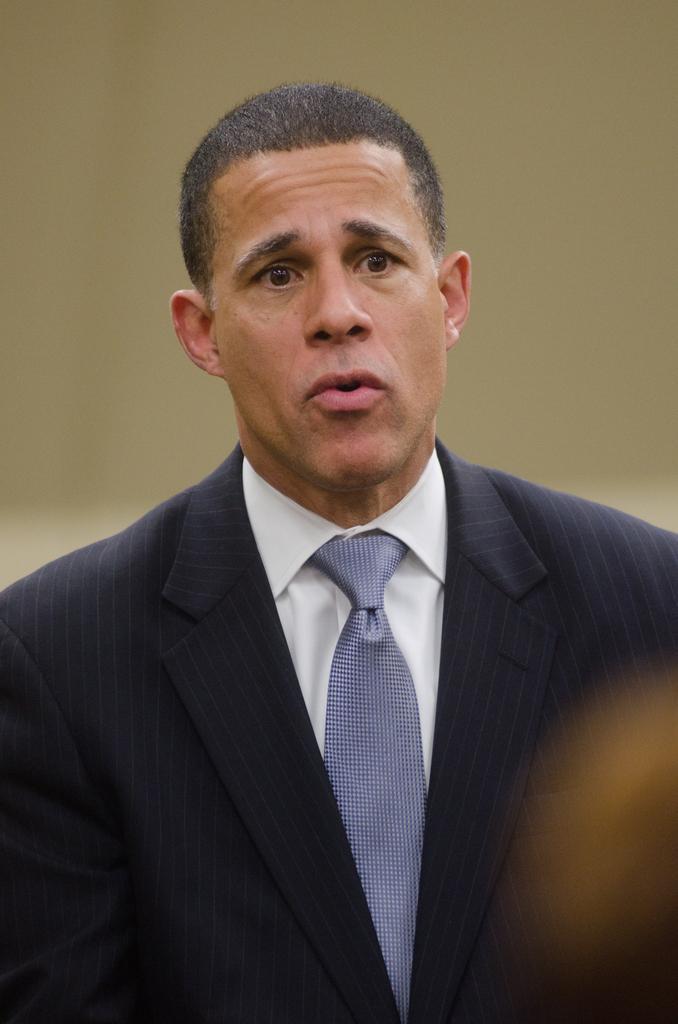Could you give a brief overview of what you see in this image? In the image there is a man,he is giving a shocking expression,he is wearing a white shirt,blue tie and blue blazer. The background of the man is blur. 